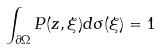Convert formula to latex. <formula><loc_0><loc_0><loc_500><loc_500>\int _ { \partial \Omega } P ( z , \xi ) d \sigma ( \xi ) = 1</formula> 